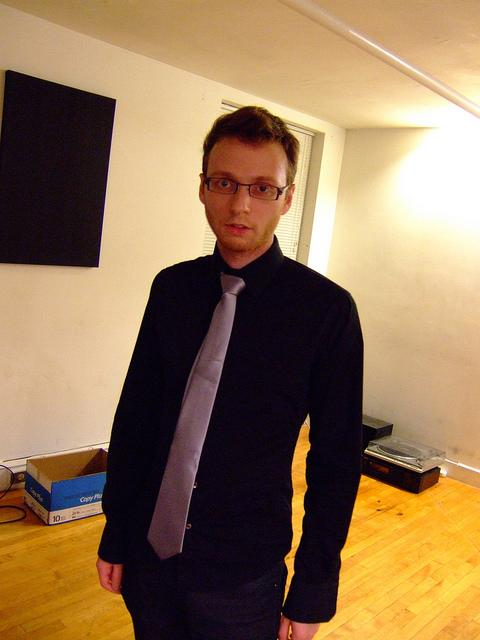What might explain the lack of furniture here?

Choices:
A) pathological illness
B) he's moving
C) poverty
D) robbery he's moving 